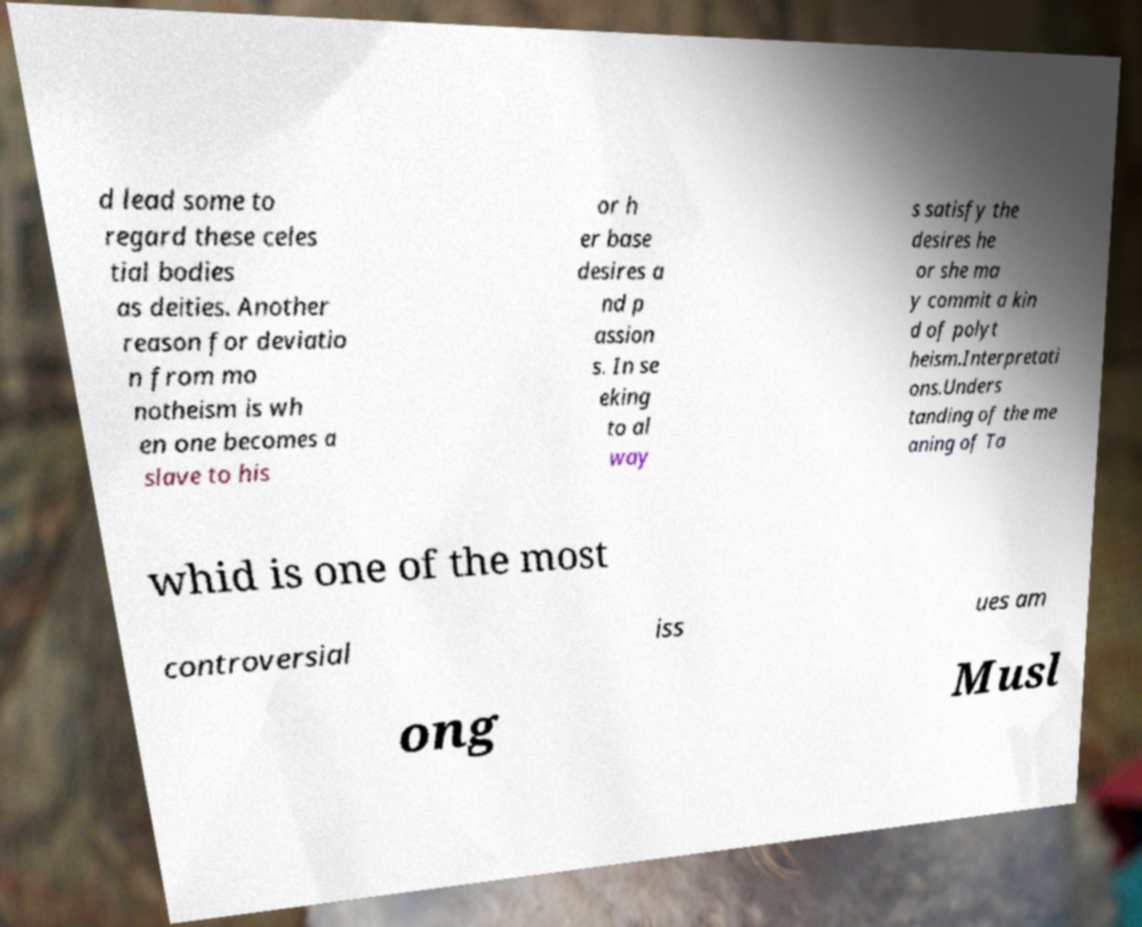I need the written content from this picture converted into text. Can you do that? d lead some to regard these celes tial bodies as deities. Another reason for deviatio n from mo notheism is wh en one becomes a slave to his or h er base desires a nd p assion s. In se eking to al way s satisfy the desires he or she ma y commit a kin d of polyt heism.Interpretati ons.Unders tanding of the me aning of Ta whid is one of the most controversial iss ues am ong Musl 